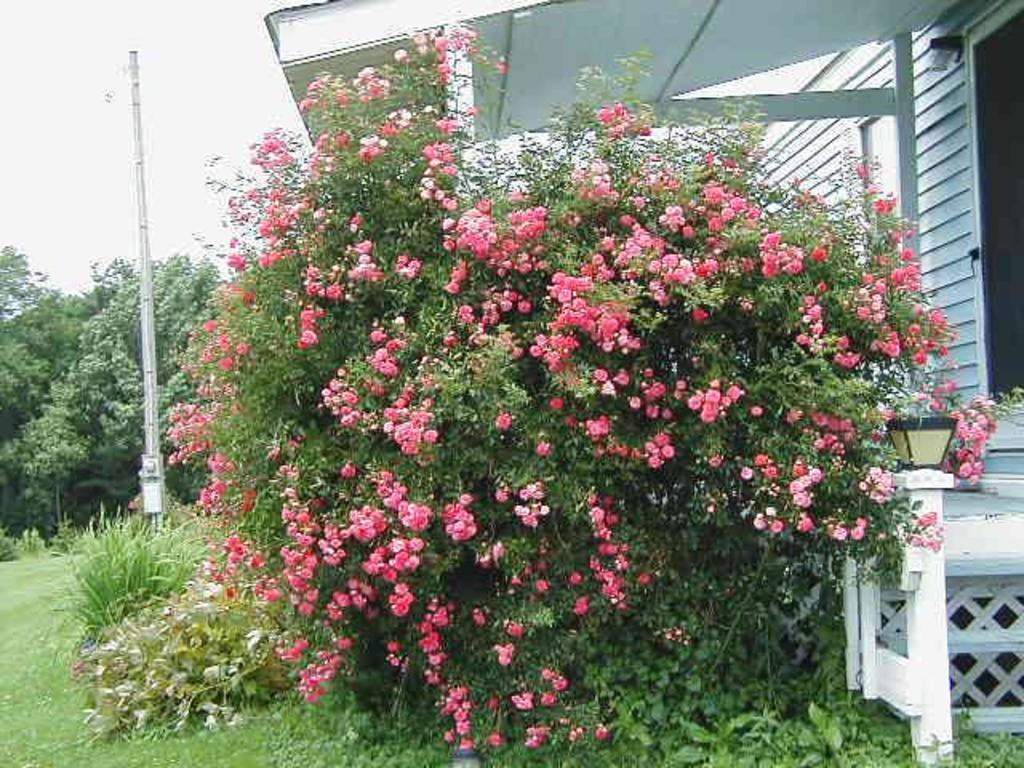In one or two sentences, can you explain what this image depicts? In this picture we can see a plant with flowers. On the left side of the image, there is a pole, trees and the sky. On the right side of the image, there is a house and a lamp. 